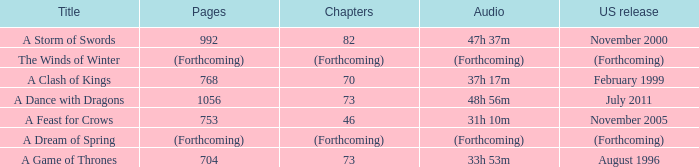Which US release has 704 pages? August 1996. 